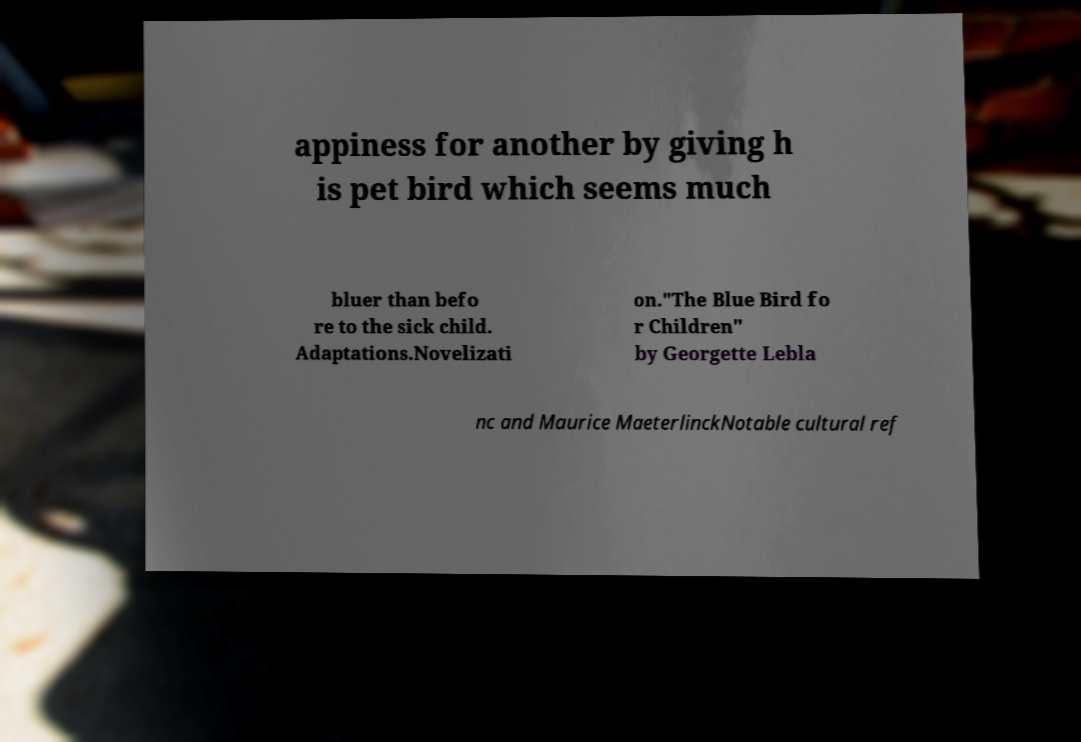I need the written content from this picture converted into text. Can you do that? appiness for another by giving h is pet bird which seems much bluer than befo re to the sick child. Adaptations.Novelizati on."The Blue Bird fo r Children" by Georgette Lebla nc and Maurice MaeterlinckNotable cultural ref 